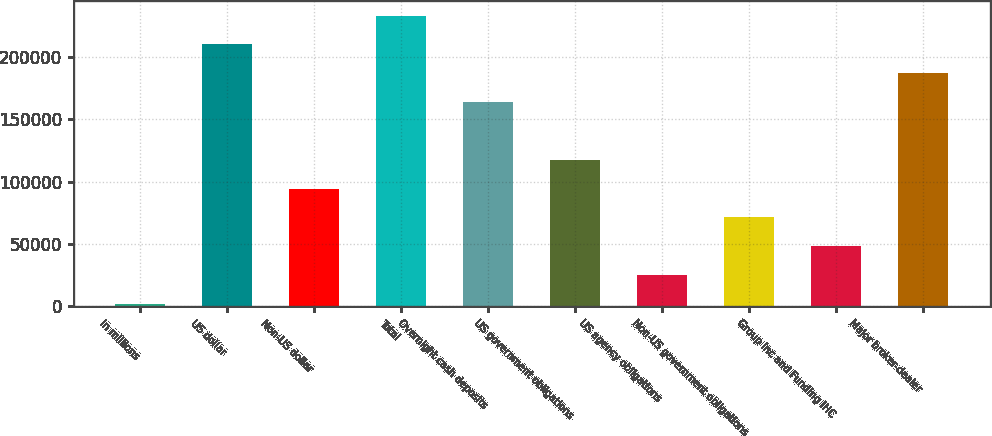Convert chart to OTSL. <chart><loc_0><loc_0><loc_500><loc_500><bar_chart><fcel>in millions<fcel>US dollar<fcel>Non-US dollar<fcel>Total<fcel>Overnight cash deposits<fcel>US government obligations<fcel>US agency obligations<fcel>Non-US government obligations<fcel>Group Inc and Funding IHC<fcel>Major broker-dealer<nl><fcel>2018<fcel>210210<fcel>94548<fcel>233343<fcel>163946<fcel>117680<fcel>25150.5<fcel>71415.5<fcel>48283<fcel>187078<nl></chart> 